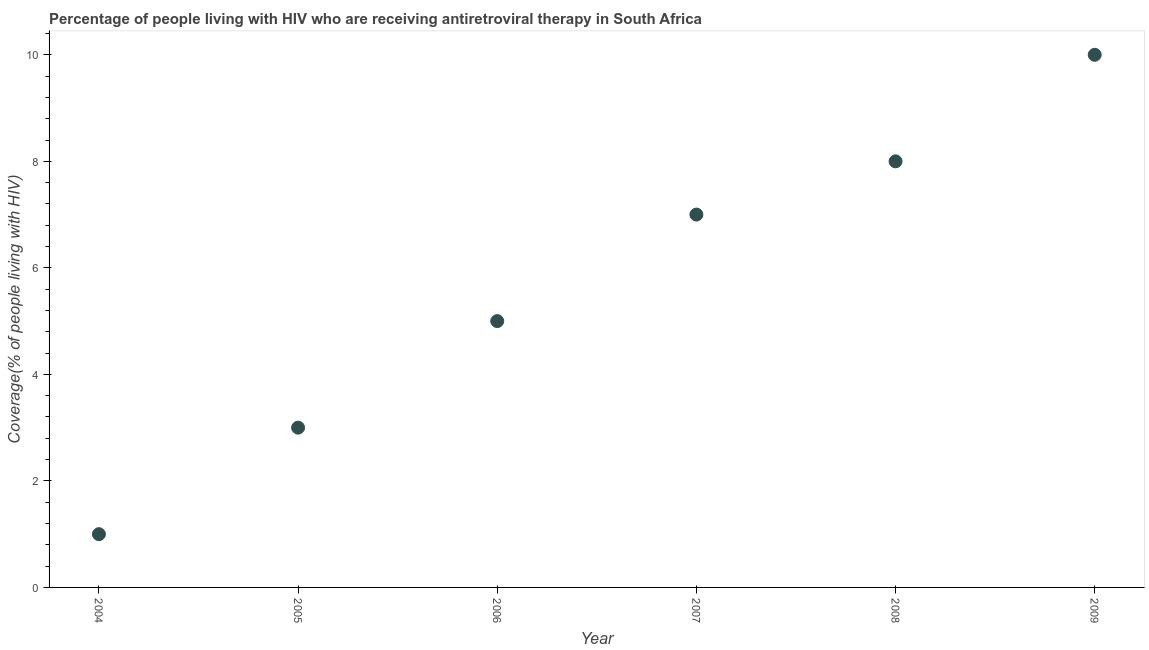What is the antiretroviral therapy coverage in 2005?
Your answer should be very brief. 3. Across all years, what is the maximum antiretroviral therapy coverage?
Keep it short and to the point. 10. Across all years, what is the minimum antiretroviral therapy coverage?
Your answer should be very brief. 1. In which year was the antiretroviral therapy coverage maximum?
Your answer should be compact. 2009. What is the sum of the antiretroviral therapy coverage?
Ensure brevity in your answer.  34. What is the difference between the antiretroviral therapy coverage in 2005 and 2008?
Give a very brief answer. -5. What is the average antiretroviral therapy coverage per year?
Your response must be concise. 5.67. In how many years, is the antiretroviral therapy coverage greater than 6 %?
Provide a succinct answer. 3. Do a majority of the years between 2009 and 2004 (inclusive) have antiretroviral therapy coverage greater than 8.4 %?
Keep it short and to the point. Yes. Is the antiretroviral therapy coverage in 2004 less than that in 2008?
Keep it short and to the point. Yes. Is the difference between the antiretroviral therapy coverage in 2006 and 2008 greater than the difference between any two years?
Your response must be concise. No. What is the difference between the highest and the second highest antiretroviral therapy coverage?
Provide a short and direct response. 2. Is the sum of the antiretroviral therapy coverage in 2004 and 2009 greater than the maximum antiretroviral therapy coverage across all years?
Keep it short and to the point. Yes. What is the difference between the highest and the lowest antiretroviral therapy coverage?
Your answer should be compact. 9. Does the antiretroviral therapy coverage monotonically increase over the years?
Provide a short and direct response. Yes. How many years are there in the graph?
Give a very brief answer. 6. Are the values on the major ticks of Y-axis written in scientific E-notation?
Your answer should be compact. No. Does the graph contain any zero values?
Your answer should be very brief. No. Does the graph contain grids?
Provide a succinct answer. No. What is the title of the graph?
Offer a very short reply. Percentage of people living with HIV who are receiving antiretroviral therapy in South Africa. What is the label or title of the Y-axis?
Give a very brief answer. Coverage(% of people living with HIV). What is the Coverage(% of people living with HIV) in 2004?
Ensure brevity in your answer.  1. What is the Coverage(% of people living with HIV) in 2005?
Provide a short and direct response. 3. What is the difference between the Coverage(% of people living with HIV) in 2004 and 2006?
Your response must be concise. -4. What is the difference between the Coverage(% of people living with HIV) in 2004 and 2007?
Make the answer very short. -6. What is the difference between the Coverage(% of people living with HIV) in 2004 and 2008?
Offer a terse response. -7. What is the difference between the Coverage(% of people living with HIV) in 2004 and 2009?
Your response must be concise. -9. What is the difference between the Coverage(% of people living with HIV) in 2005 and 2007?
Make the answer very short. -4. What is the difference between the Coverage(% of people living with HIV) in 2006 and 2009?
Your answer should be very brief. -5. What is the ratio of the Coverage(% of people living with HIV) in 2004 to that in 2005?
Make the answer very short. 0.33. What is the ratio of the Coverage(% of people living with HIV) in 2004 to that in 2007?
Your response must be concise. 0.14. What is the ratio of the Coverage(% of people living with HIV) in 2004 to that in 2008?
Offer a terse response. 0.12. What is the ratio of the Coverage(% of people living with HIV) in 2004 to that in 2009?
Offer a very short reply. 0.1. What is the ratio of the Coverage(% of people living with HIV) in 2005 to that in 2007?
Your response must be concise. 0.43. What is the ratio of the Coverage(% of people living with HIV) in 2005 to that in 2008?
Your response must be concise. 0.38. What is the ratio of the Coverage(% of people living with HIV) in 2006 to that in 2007?
Offer a terse response. 0.71. What is the ratio of the Coverage(% of people living with HIV) in 2006 to that in 2008?
Your answer should be compact. 0.62. What is the ratio of the Coverage(% of people living with HIV) in 2006 to that in 2009?
Your answer should be very brief. 0.5. What is the ratio of the Coverage(% of people living with HIV) in 2007 to that in 2008?
Keep it short and to the point. 0.88. What is the ratio of the Coverage(% of people living with HIV) in 2007 to that in 2009?
Offer a very short reply. 0.7. 